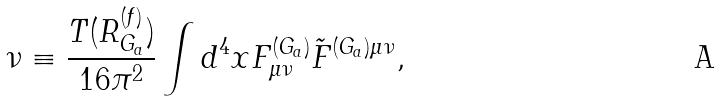Convert formula to latex. <formula><loc_0><loc_0><loc_500><loc_500>\nu \equiv \frac { T ( { R } ^ { ( f ) } _ { G _ { a } } ) } { 1 6 \pi ^ { 2 } } \int d ^ { 4 } x F ^ { ( G _ { a } ) } _ { \mu \nu } \tilde { F } ^ { { ( G _ { a } ) } \mu \nu } ,</formula> 